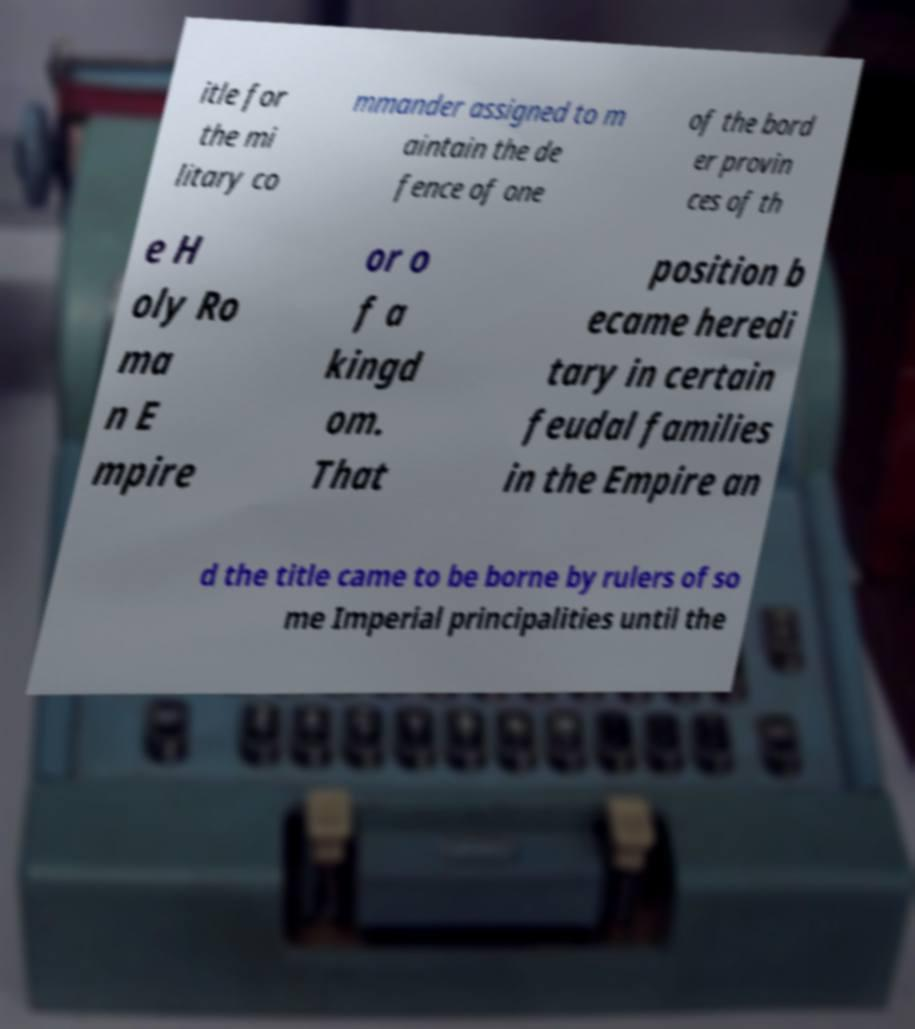Could you assist in decoding the text presented in this image and type it out clearly? itle for the mi litary co mmander assigned to m aintain the de fence of one of the bord er provin ces of th e H oly Ro ma n E mpire or o f a kingd om. That position b ecame heredi tary in certain feudal families in the Empire an d the title came to be borne by rulers of so me Imperial principalities until the 